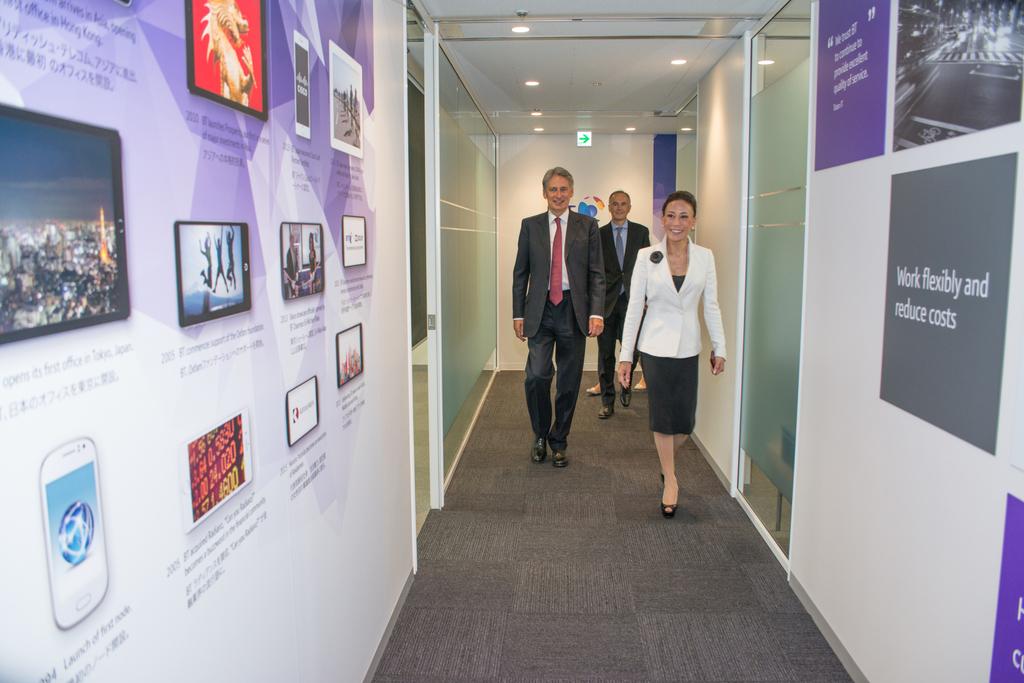What does the grey sign on the right say?
Give a very brief answer. Work flexibly and reduce costs. 